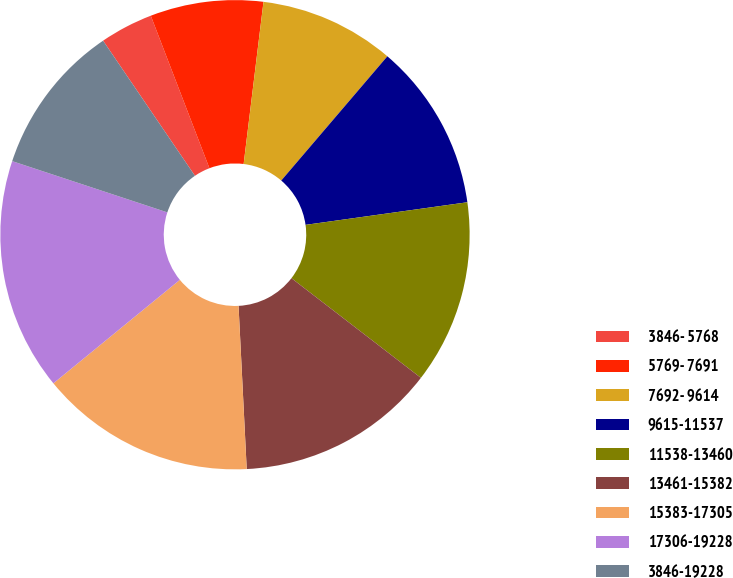Convert chart to OTSL. <chart><loc_0><loc_0><loc_500><loc_500><pie_chart><fcel>3846- 5768<fcel>5769- 7691<fcel>7692- 9614<fcel>9615-11537<fcel>11538-13460<fcel>13461-15382<fcel>15383-17305<fcel>17306-19228<fcel>3846-19228<nl><fcel>3.66%<fcel>7.78%<fcel>9.31%<fcel>11.54%<fcel>12.65%<fcel>13.76%<fcel>14.88%<fcel>15.99%<fcel>10.42%<nl></chart> 